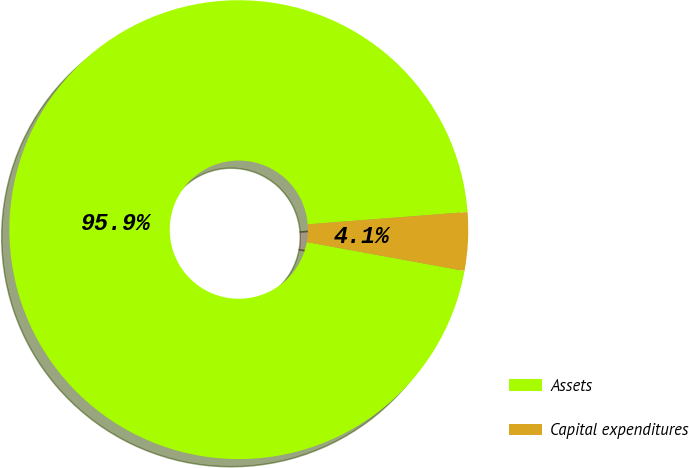<chart> <loc_0><loc_0><loc_500><loc_500><pie_chart><fcel>Assets<fcel>Capital expenditures<nl><fcel>95.9%<fcel>4.1%<nl></chart> 